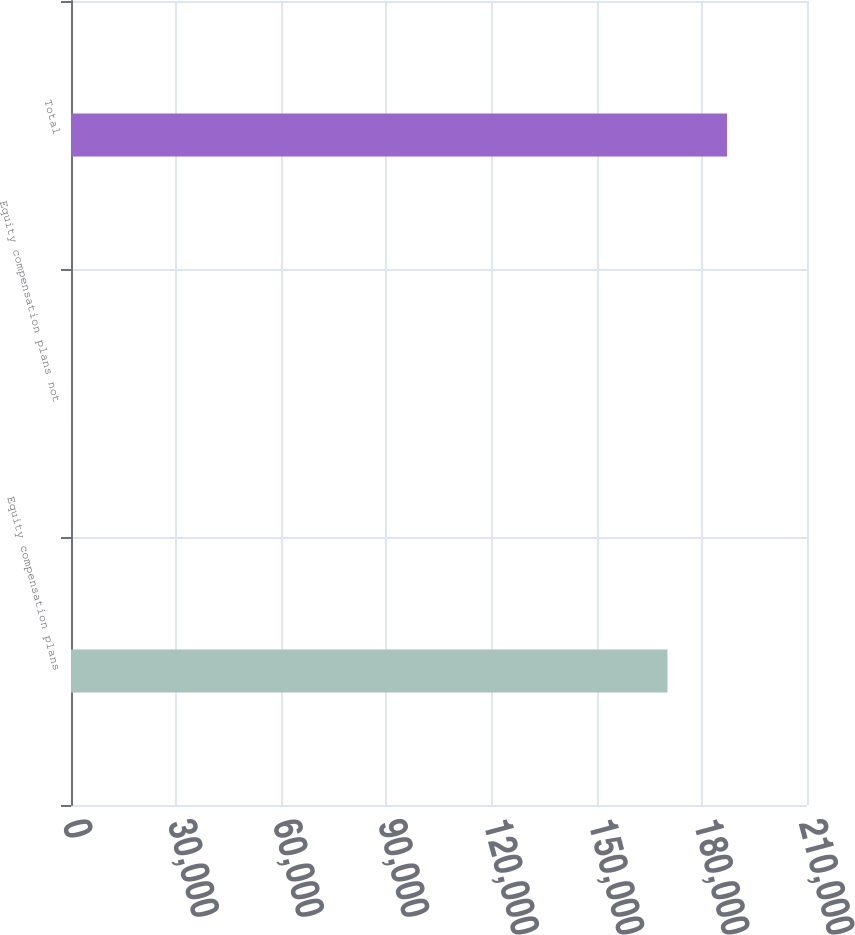<chart> <loc_0><loc_0><loc_500><loc_500><bar_chart><fcel>Equity compensation plans<fcel>Equity compensation plans not<fcel>Total<nl><fcel>170176<fcel>2.93<fcel>187193<nl></chart> 